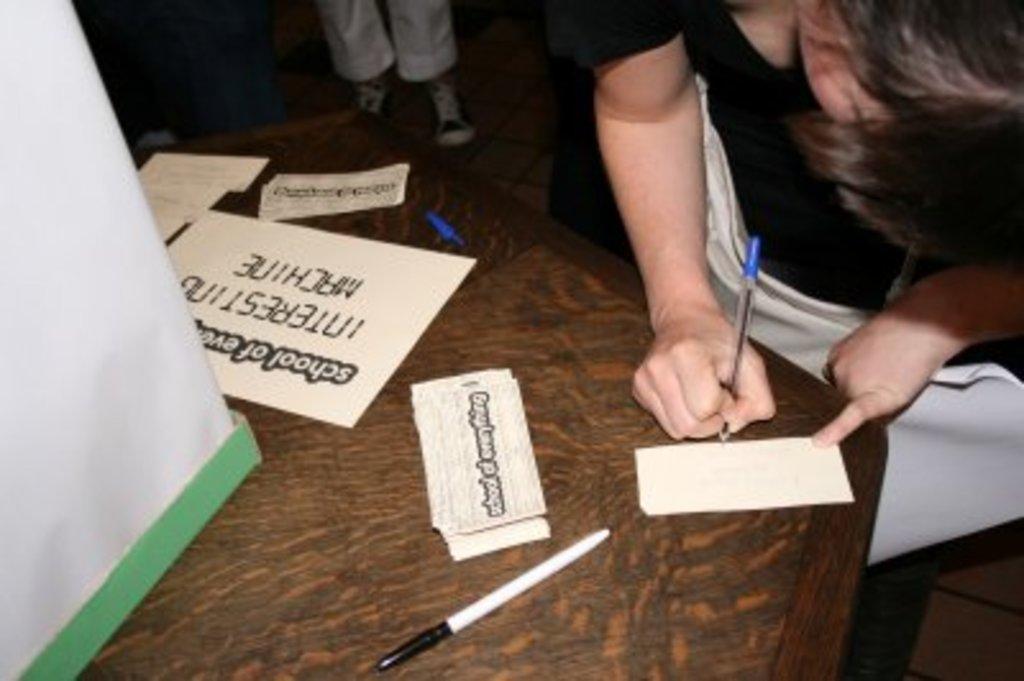Please provide a concise description of this image. In this image, there are a few people. Among them, we can see a person holding an object. We can see a table with some objects like posters. We can also see a white colored object on the left. We can see the ground. 